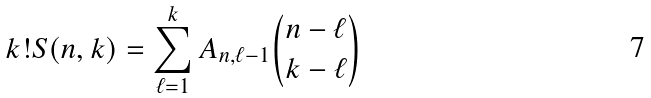<formula> <loc_0><loc_0><loc_500><loc_500>k ! S ( n , k ) = \sum _ { \ell = 1 } ^ { k } A _ { n , \ell - 1 } \binom { n - \ell } { k - \ell }</formula> 